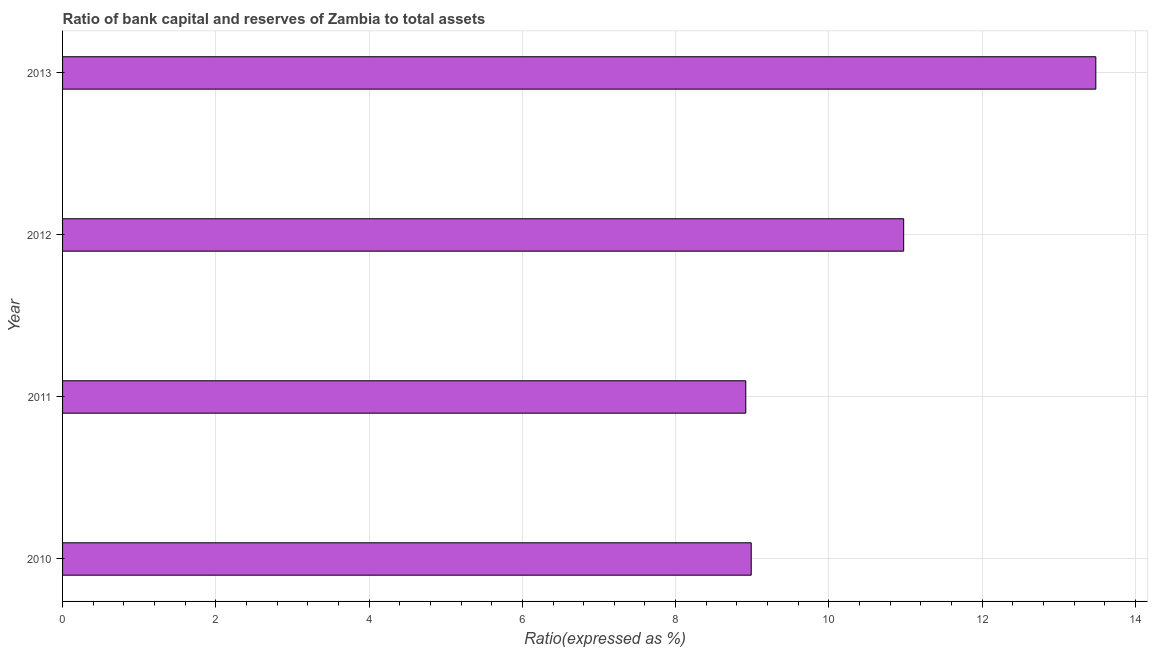Does the graph contain any zero values?
Your answer should be very brief. No. What is the title of the graph?
Offer a very short reply. Ratio of bank capital and reserves of Zambia to total assets. What is the label or title of the X-axis?
Give a very brief answer. Ratio(expressed as %). What is the bank capital to assets ratio in 2012?
Your answer should be very brief. 10.98. Across all years, what is the maximum bank capital to assets ratio?
Offer a very short reply. 13.48. Across all years, what is the minimum bank capital to assets ratio?
Offer a very short reply. 8.92. In which year was the bank capital to assets ratio minimum?
Give a very brief answer. 2011. What is the sum of the bank capital to assets ratio?
Offer a terse response. 42.36. What is the difference between the bank capital to assets ratio in 2011 and 2012?
Provide a succinct answer. -2.06. What is the average bank capital to assets ratio per year?
Make the answer very short. 10.59. What is the median bank capital to assets ratio?
Offer a terse response. 9.98. In how many years, is the bank capital to assets ratio greater than 7.2 %?
Provide a short and direct response. 4. What is the ratio of the bank capital to assets ratio in 2010 to that in 2012?
Offer a terse response. 0.82. What is the difference between the highest and the second highest bank capital to assets ratio?
Offer a terse response. 2.51. Is the sum of the bank capital to assets ratio in 2010 and 2011 greater than the maximum bank capital to assets ratio across all years?
Keep it short and to the point. Yes. What is the difference between the highest and the lowest bank capital to assets ratio?
Give a very brief answer. 4.57. How many bars are there?
Your answer should be compact. 4. Are all the bars in the graph horizontal?
Offer a very short reply. Yes. How many years are there in the graph?
Give a very brief answer. 4. What is the difference between two consecutive major ticks on the X-axis?
Your response must be concise. 2. What is the Ratio(expressed as %) of 2010?
Your answer should be very brief. 8.99. What is the Ratio(expressed as %) in 2011?
Keep it short and to the point. 8.92. What is the Ratio(expressed as %) in 2012?
Give a very brief answer. 10.98. What is the Ratio(expressed as %) in 2013?
Offer a very short reply. 13.48. What is the difference between the Ratio(expressed as %) in 2010 and 2011?
Make the answer very short. 0.07. What is the difference between the Ratio(expressed as %) in 2010 and 2012?
Your answer should be compact. -1.99. What is the difference between the Ratio(expressed as %) in 2010 and 2013?
Make the answer very short. -4.5. What is the difference between the Ratio(expressed as %) in 2011 and 2012?
Your answer should be very brief. -2.06. What is the difference between the Ratio(expressed as %) in 2011 and 2013?
Your answer should be compact. -4.57. What is the difference between the Ratio(expressed as %) in 2012 and 2013?
Offer a very short reply. -2.51. What is the ratio of the Ratio(expressed as %) in 2010 to that in 2012?
Ensure brevity in your answer.  0.82. What is the ratio of the Ratio(expressed as %) in 2010 to that in 2013?
Give a very brief answer. 0.67. What is the ratio of the Ratio(expressed as %) in 2011 to that in 2012?
Offer a terse response. 0.81. What is the ratio of the Ratio(expressed as %) in 2011 to that in 2013?
Ensure brevity in your answer.  0.66. What is the ratio of the Ratio(expressed as %) in 2012 to that in 2013?
Make the answer very short. 0.81. 